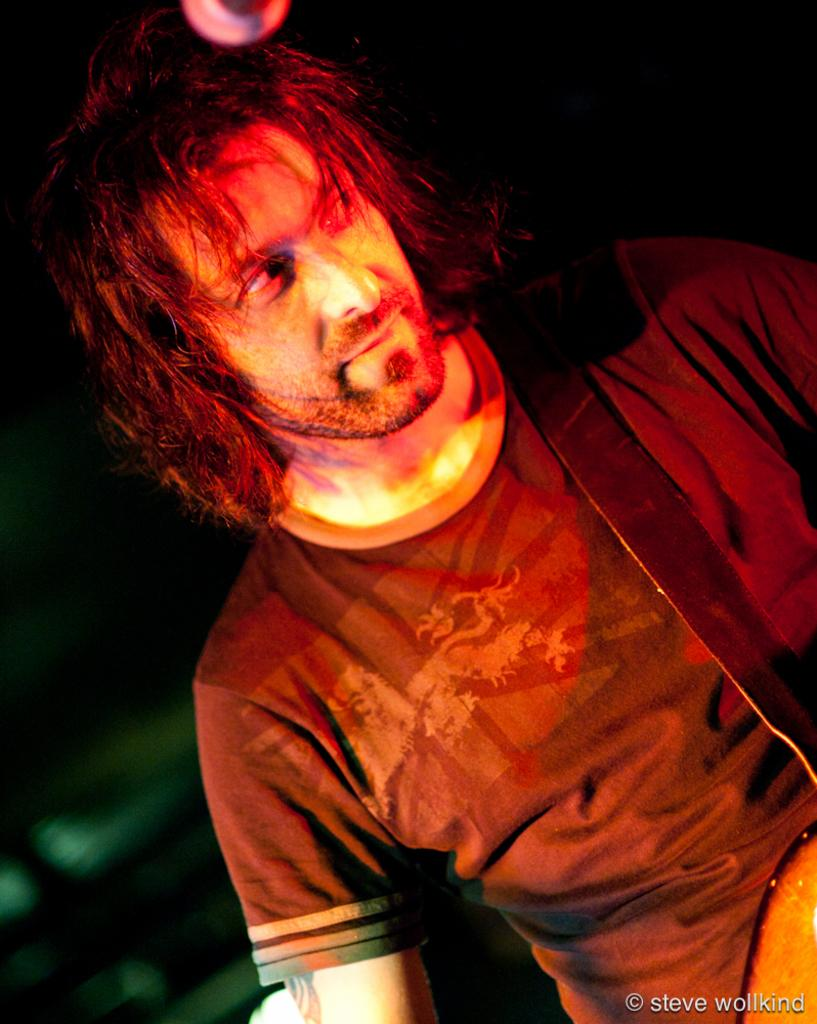What is the main subject of the image? The main subject of the image is a man. What is the man doing in the image? The man is standing in the image. What object is the man holding in the image? The man is holding a guitar in the image. What other object is present in the image? There is a microphone in the image. What type of theory can be seen being developed on the floor in the image? There is no theory being developed on the floor in the image. How does the dust accumulate on the guitar in the image? There is no dust visible in the image, and therefore no accumulation can be observed. 